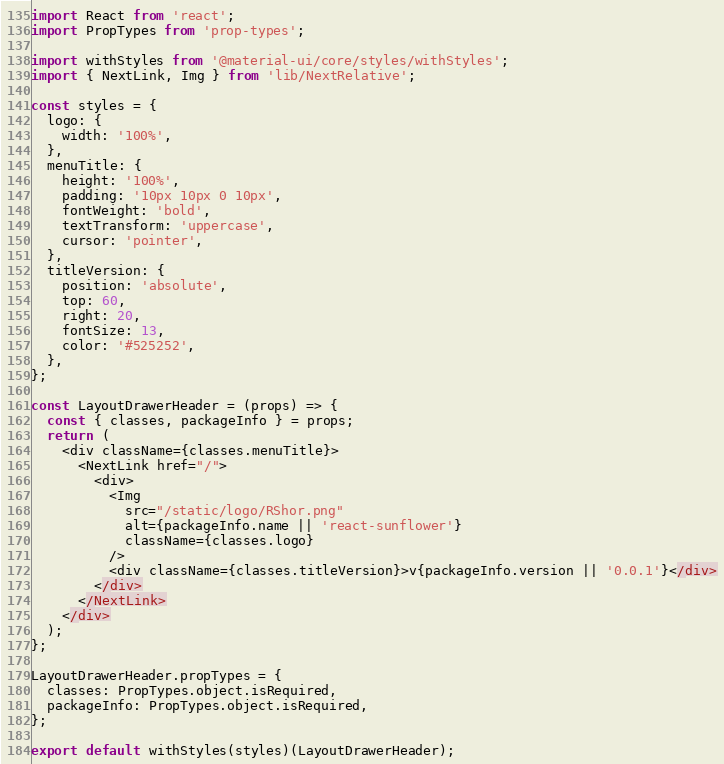Convert code to text. <code><loc_0><loc_0><loc_500><loc_500><_JavaScript_>import React from 'react';
import PropTypes from 'prop-types';

import withStyles from '@material-ui/core/styles/withStyles';
import { NextLink, Img } from 'lib/NextRelative';

const styles = {
  logo: {
    width: '100%',
  },
  menuTitle: {
    height: '100%',
    padding: '10px 10px 0 10px',
    fontWeight: 'bold',
    textTransform: 'uppercase',
    cursor: 'pointer',
  },
  titleVersion: {
    position: 'absolute',
    top: 60,
    right: 20,
    fontSize: 13,
    color: '#525252',
  },
};

const LayoutDrawerHeader = (props) => {
  const { classes, packageInfo } = props;
  return (
    <div className={classes.menuTitle}>
      <NextLink href="/">
        <div>
          <Img
            src="/static/logo/RShor.png"
            alt={packageInfo.name || 'react-sunflower'}
            className={classes.logo}
          />
          <div className={classes.titleVersion}>v{packageInfo.version || '0.0.1'}</div>
        </div>
      </NextLink>
    </div>
  );
};

LayoutDrawerHeader.propTypes = {
  classes: PropTypes.object.isRequired,
  packageInfo: PropTypes.object.isRequired,
};

export default withStyles(styles)(LayoutDrawerHeader);
</code> 